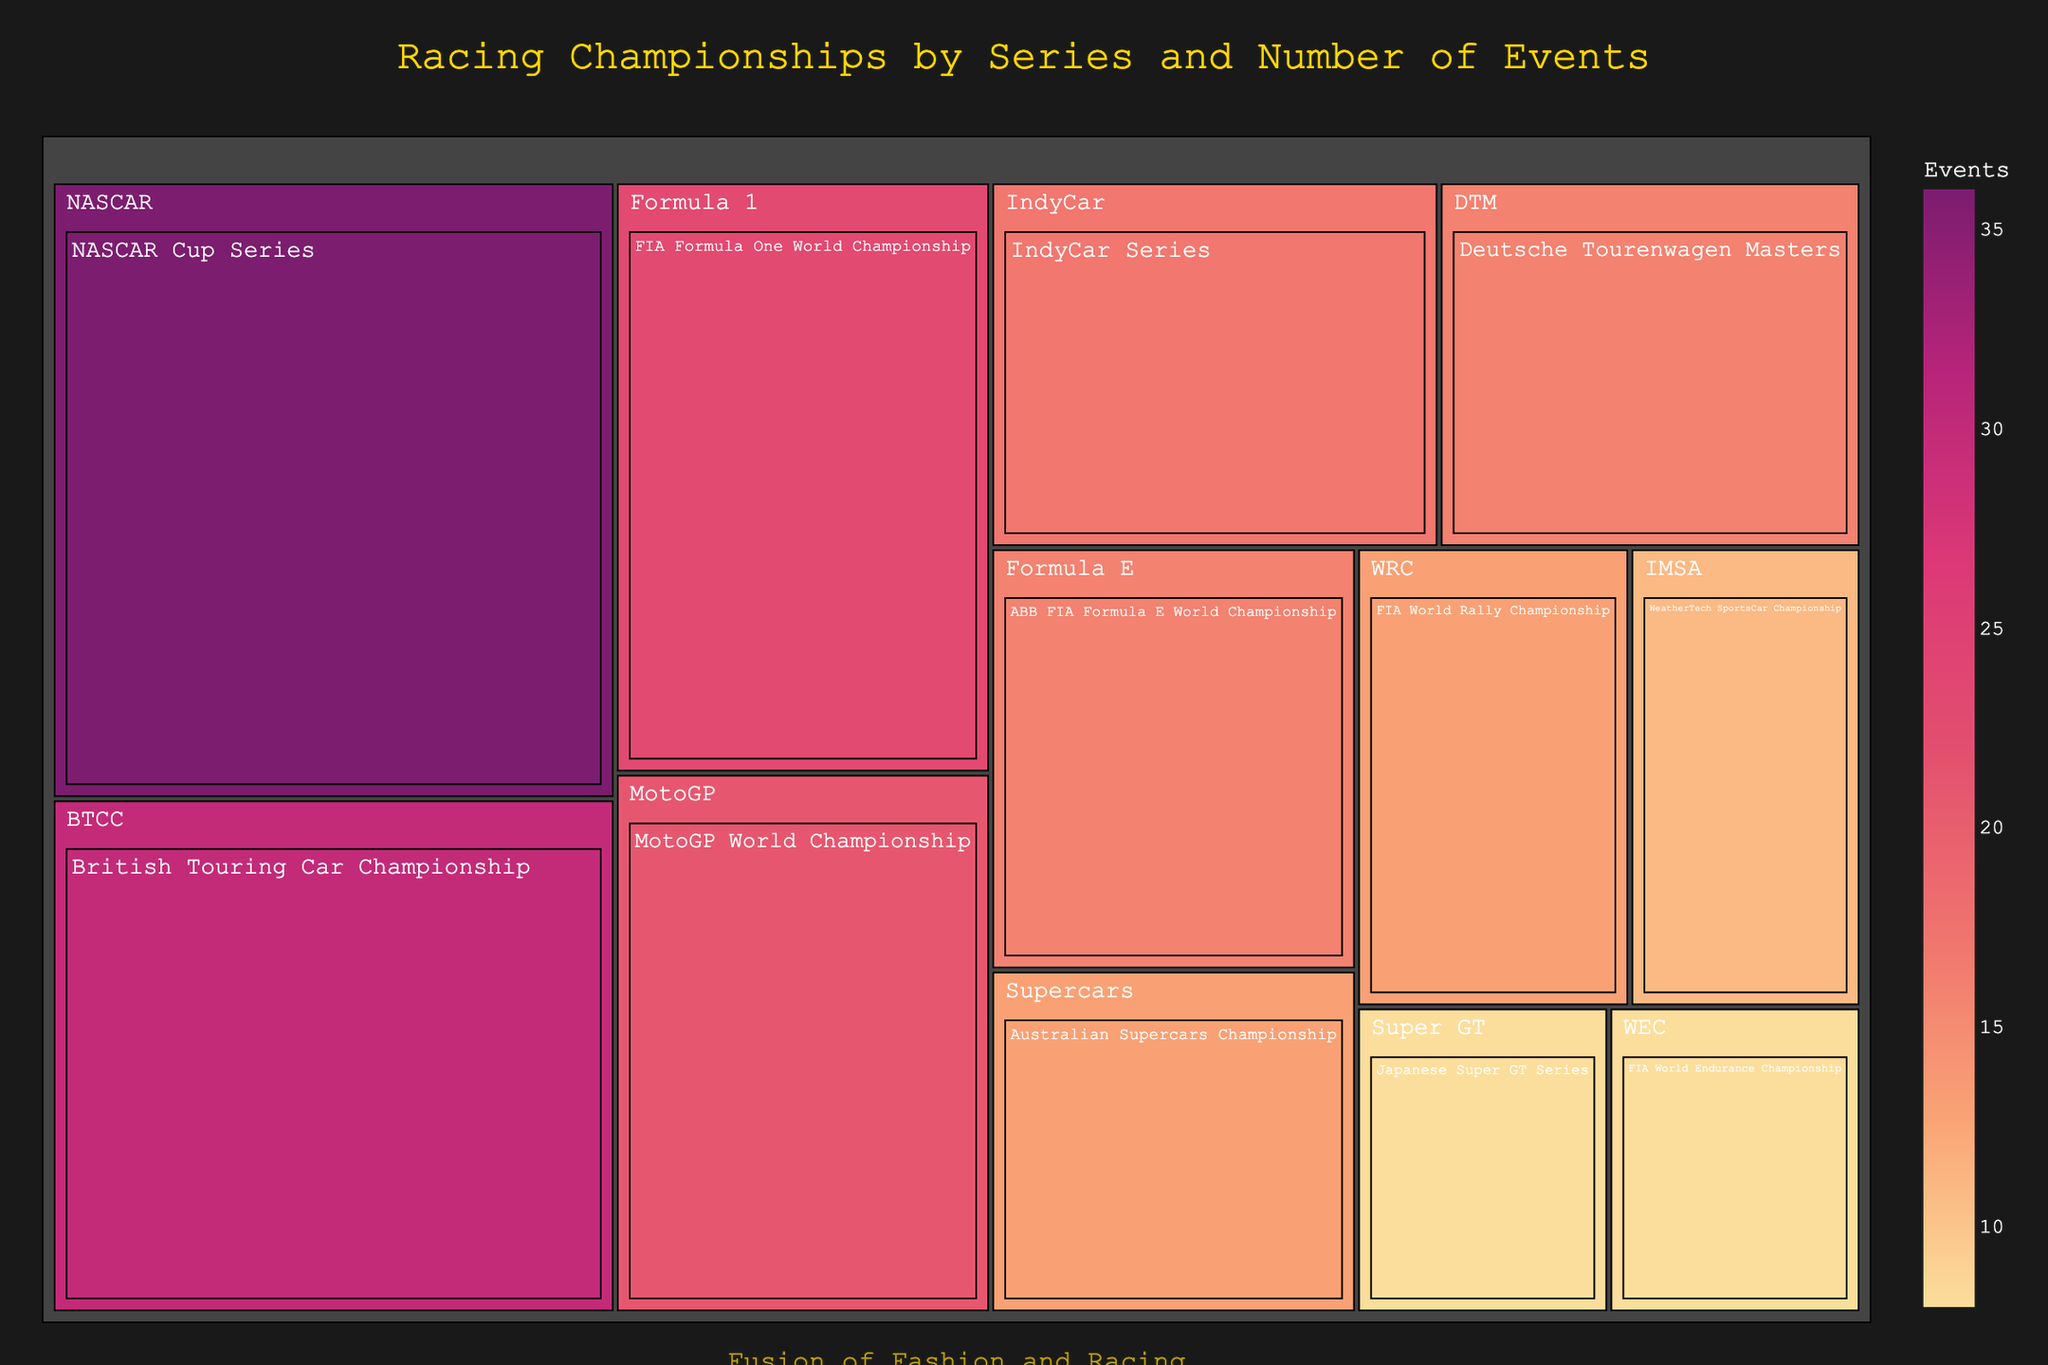What is the title of the Treemap? The title is clearly stated at the top of the Treemap. It reads "Racing Championships by Series and Number of Events".
Answer: Racing Championships by Series and Number of Events Which series has the highest number of events? The series with the highest number of events has a larger area in the Treemap. Based on the Treemap, the NASCAR Cup Series has the largest area representing 36 events.
Answer: NASCAR Cup Series How many events does the Formula 1 series have? Locate the Formula 1 series on the Treemap and observe the number indicated. The Treemap shows that the FIA Formula One World Championship has 23 events.
Answer: 23 events Which motorsport series have exactly 16 events? Find the series with a size representing 16 events on the Treemap. Based on the Treemap, there are two series: ABB FIA Formula E World Championship and Deutsche Tourenwagen Masters (DTM), both have 16 events.
Answer: Formula E and DTM Compare the number of events between MotoGP and Supercars championships. Which one has more events, and by how many? Locate both the MotoGP World Championship and the Australian Supercars Championship on the Treemap. MotoGP has 21 events, while Supercars has 13 events. The difference is 21 - 13 = 8. Thus, MotoGP has 8 more events than Supercars.
Answer: MotoGP has 8 more events What is the total number of events for all championships combined? Sum the number of events for all the series displayed in the Treemap. The total is calculated as 36 (NASCAR) + 23 (F1) + 21 (MotoGP) + 17 (IndyCar) + 16 (Formula E) + 16 (DTM) + 13 (Supercars) + 13 (WRC) + 11 (IMSA) + 8 (WEC) + 8 (Super GT) + 30 (BTCC) = 212. The total number of events is 212.
Answer: 212 events Which championship is represented by the smallest area in the Treemap and how many events does it have? Identify the smallest area in the Treemap which represents the minimum number of events. The area representing 8 events is the smallest and corresponds to both the FIA World Endurance Championship (WEC) and Japanese Super GT Series.
Answer: WEC and Super GT, 8 events How many more events does the British Touring Car Championship (BTCC) have compared to the WeatherTech SportsCar Championship (IMSA)? Locate both the BTCC and IMSA on the Treemap. BTCC has 30 events while IMSA has 11 events. The difference is calculated as 30 - 11 = 19. Hence, BTCC has 19 more events than IMSA.
Answer: BTCC has 19 more events 